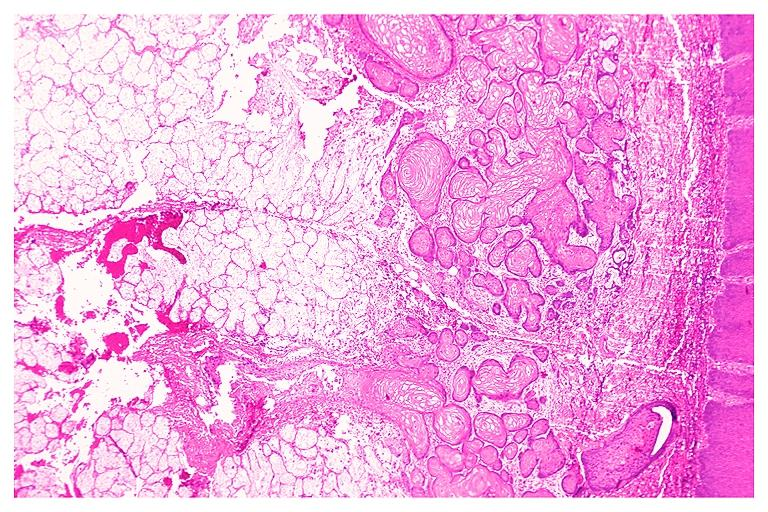what does this image show?
Answer the question using a single word or phrase. Necrotizing sialometaplasia 